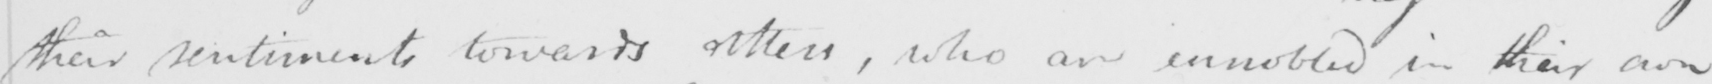Transcribe the text shown in this historical manuscript line. their sentiments towards others , who are ennobled in their own 